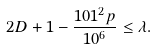<formula> <loc_0><loc_0><loc_500><loc_500>2 D + 1 - \frac { 1 0 1 ^ { 2 } p } { 1 0 ^ { 6 } } \leq \lambda .</formula> 